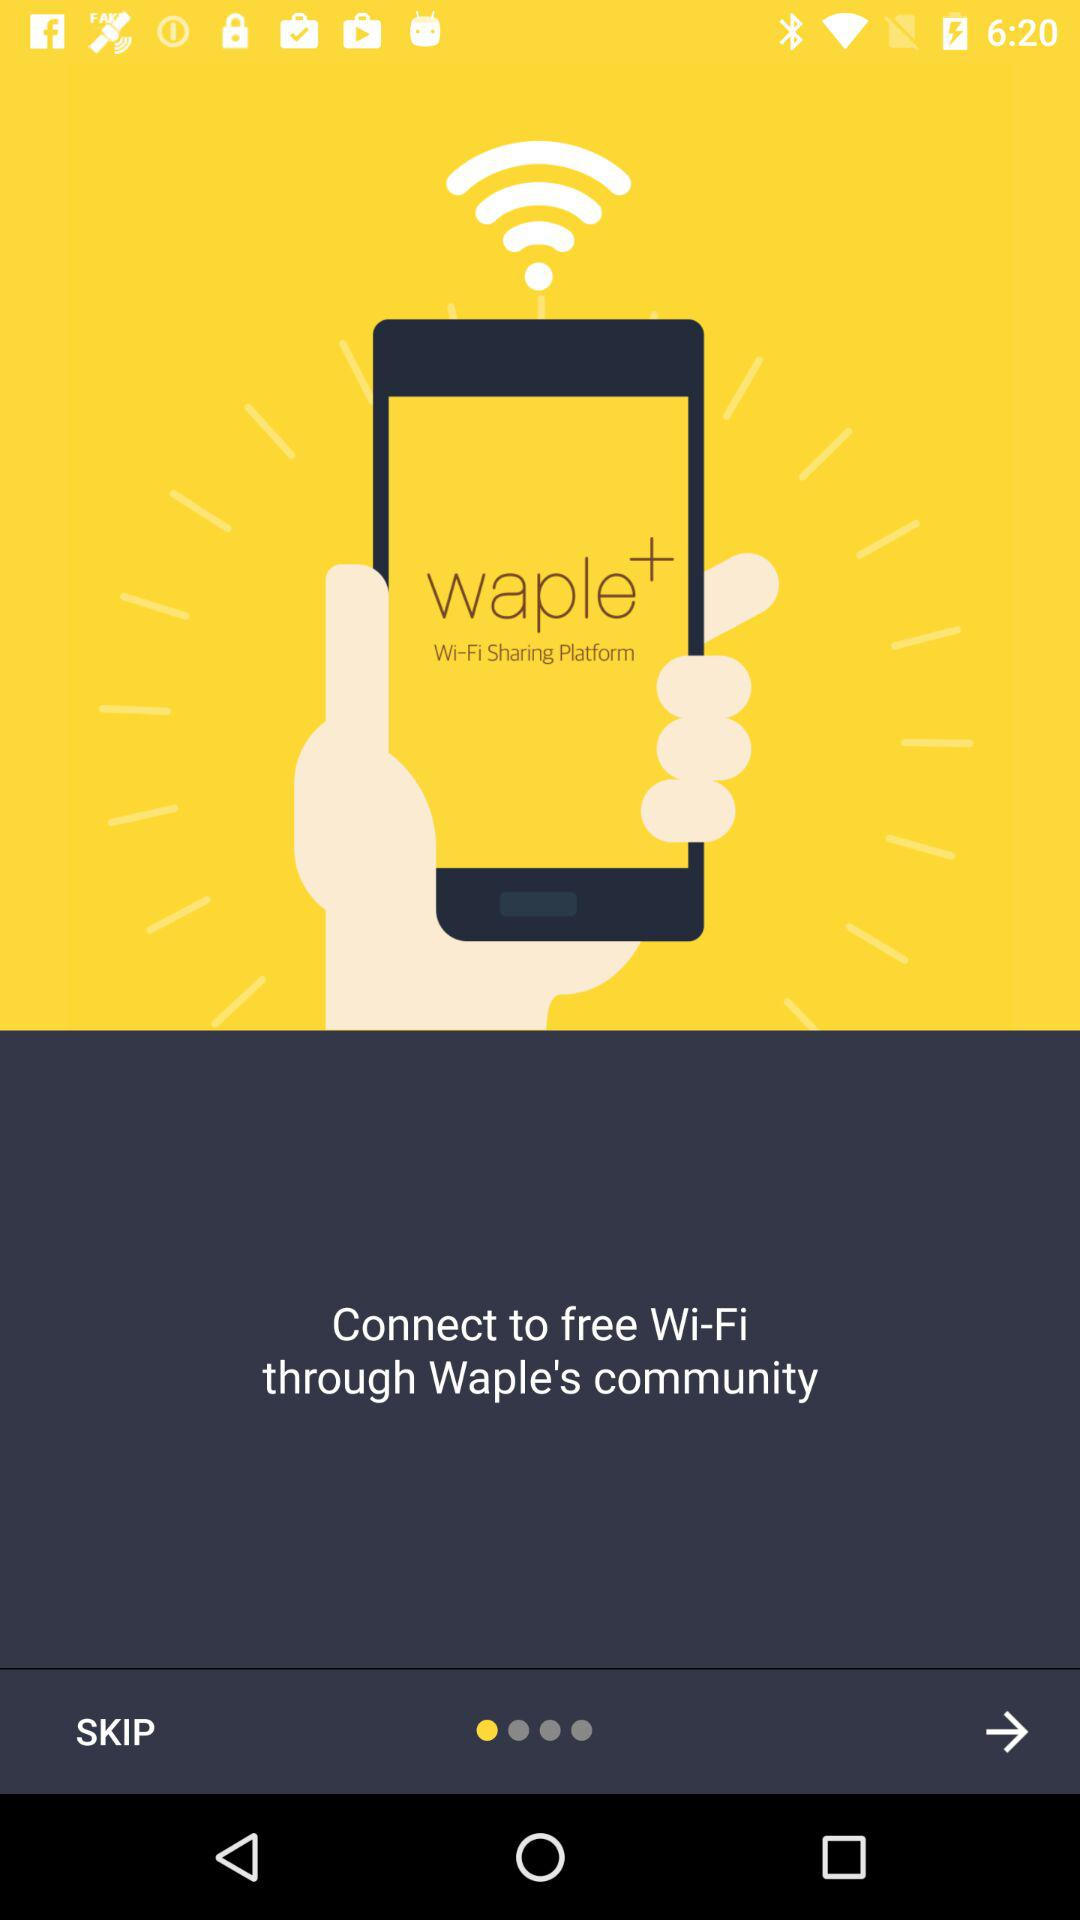How do I connect to free Wi-Fi? You can connect to free Wi-Fi through Waple's community. 